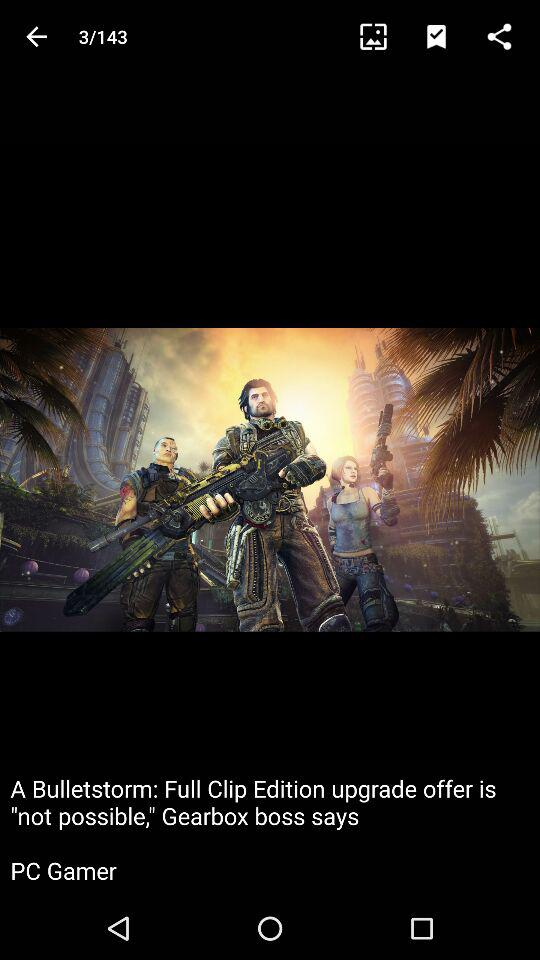On which image am I? You are on image 3. 